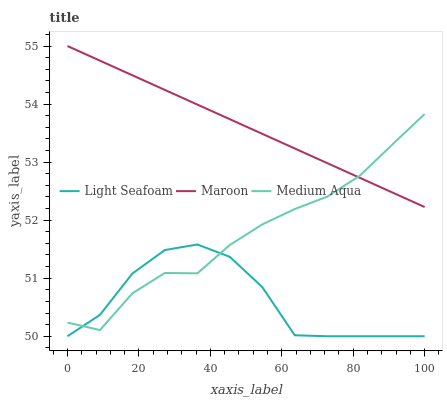Does Light Seafoam have the minimum area under the curve?
Answer yes or no. Yes. Does Maroon have the maximum area under the curve?
Answer yes or no. Yes. Does Medium Aqua have the minimum area under the curve?
Answer yes or no. No. Does Medium Aqua have the maximum area under the curve?
Answer yes or no. No. Is Maroon the smoothest?
Answer yes or no. Yes. Is Light Seafoam the roughest?
Answer yes or no. Yes. Is Medium Aqua the smoothest?
Answer yes or no. No. Is Medium Aqua the roughest?
Answer yes or no. No. Does Light Seafoam have the lowest value?
Answer yes or no. Yes. Does Medium Aqua have the lowest value?
Answer yes or no. No. Does Maroon have the highest value?
Answer yes or no. Yes. Does Medium Aqua have the highest value?
Answer yes or no. No. Is Light Seafoam less than Maroon?
Answer yes or no. Yes. Is Maroon greater than Light Seafoam?
Answer yes or no. Yes. Does Medium Aqua intersect Maroon?
Answer yes or no. Yes. Is Medium Aqua less than Maroon?
Answer yes or no. No. Is Medium Aqua greater than Maroon?
Answer yes or no. No. Does Light Seafoam intersect Maroon?
Answer yes or no. No. 